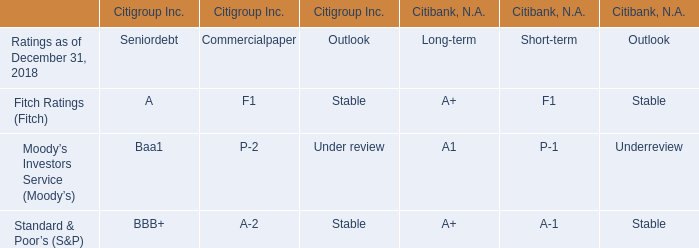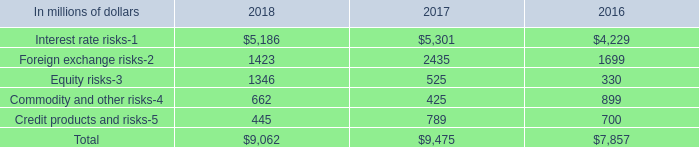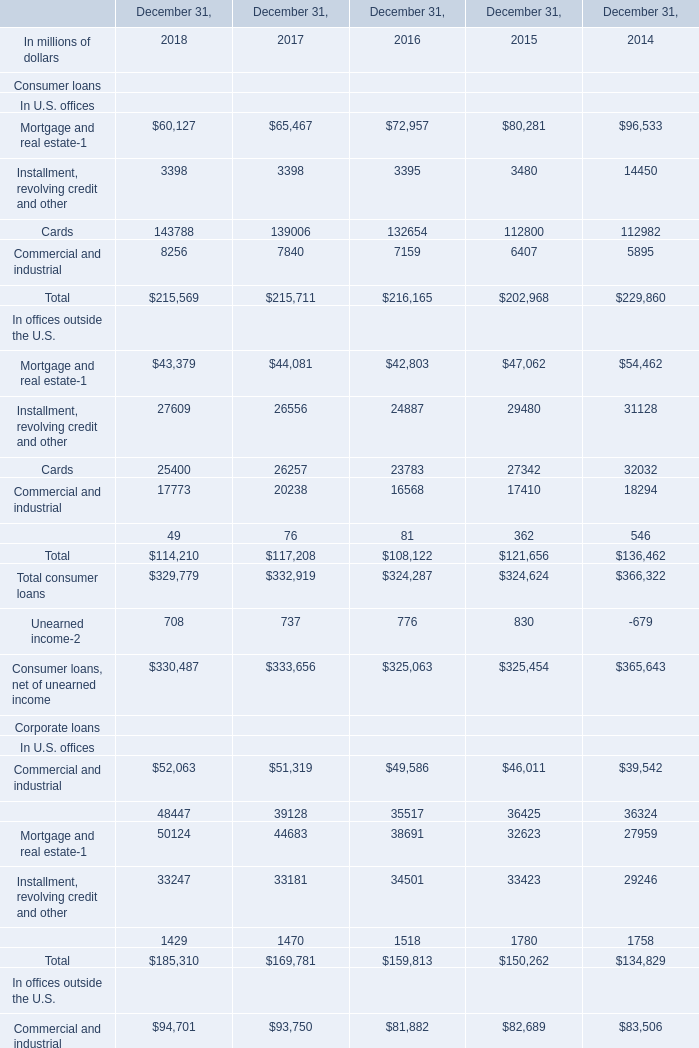what was the percent change of the principal transactions revenue associated with interest rate risks from 2016 to 2017 
Computations: ((5301 - 4229) / 4229)
Answer: 0.25349. 